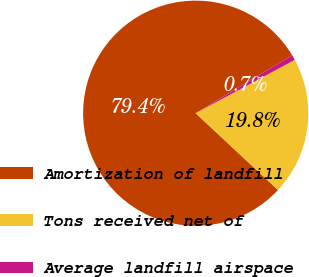Convert chart to OTSL. <chart><loc_0><loc_0><loc_500><loc_500><pie_chart><fcel>Amortization of landfill<fcel>Tons received net of<fcel>Average landfill airspace<nl><fcel>79.44%<fcel>19.81%<fcel>0.74%<nl></chart> 